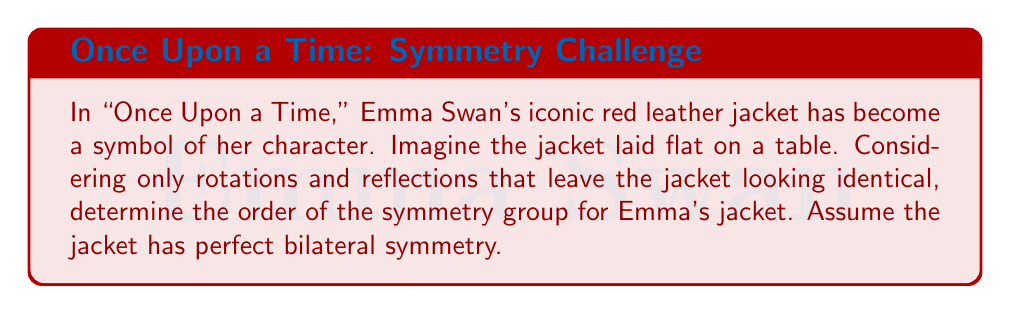What is the answer to this math problem? To solve this problem, let's consider the symmetries of Emma Swan's red leather jacket:

1. Rotational symmetries:
   - Identity (0° rotation)
   - 180° rotation (turning the jacket upside down)

2. Reflection symmetries:
   - Vertical reflection (along the center line of the jacket)
   - Horizontal reflection (across the waist of the jacket)

These symmetries form a group under composition. Let's identify the elements:

$$G = \{e, r, h, v\}$$

Where:
$e$ = identity transformation
$r$ = 180° rotation
$h$ = horizontal reflection
$v$ = vertical reflection

We can verify that this set forms a group:
- It's closed under composition
- The identity element $e$ exists
- Each element has an inverse (in fact, each element is its own inverse)
- Composition is associative

To determine the order of the group, we simply count the number of elements in the set $G$.

$$|G| = |\{e, r, h, v\}| = 4$$

Interestingly, this group is isomorphic to the Klein four-group, $V_4$, which is an abelian group of order 4.
Answer: The order of the symmetry group for Emma Swan's iconic red leather jacket is 4. 